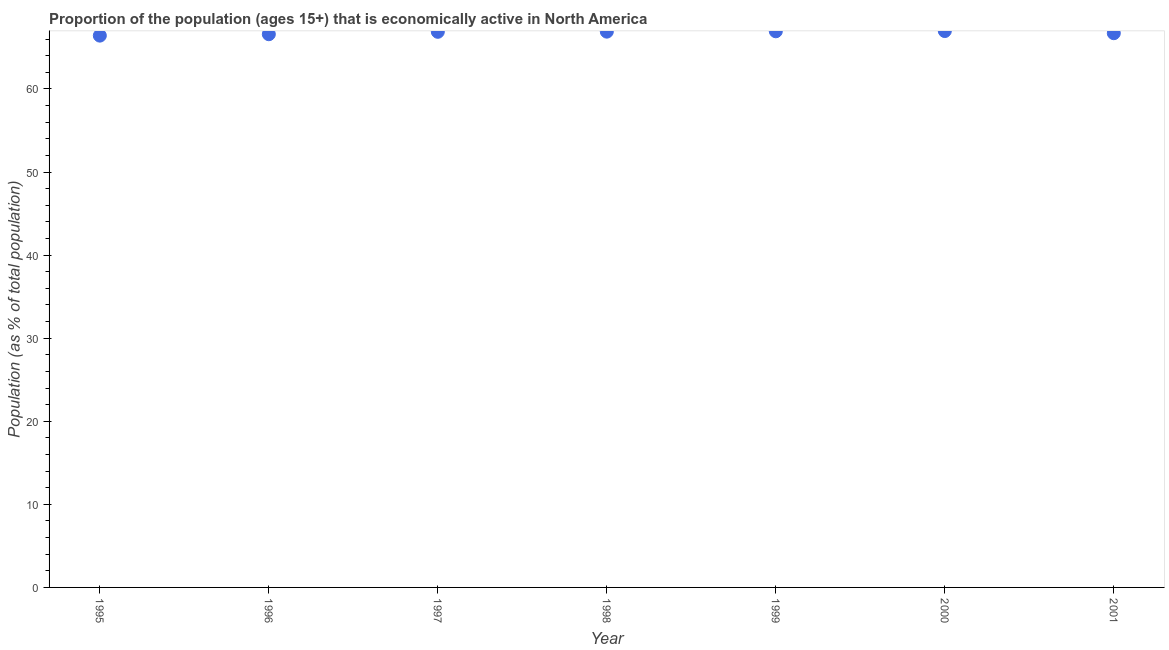What is the percentage of economically active population in 2000?
Offer a very short reply. 66.97. Across all years, what is the maximum percentage of economically active population?
Make the answer very short. 66.97. Across all years, what is the minimum percentage of economically active population?
Offer a terse response. 66.42. What is the sum of the percentage of economically active population?
Your response must be concise. 467.4. What is the difference between the percentage of economically active population in 1995 and 1996?
Your answer should be compact. -0.17. What is the average percentage of economically active population per year?
Offer a terse response. 66.77. What is the median percentage of economically active population?
Ensure brevity in your answer.  66.88. What is the ratio of the percentage of economically active population in 1995 to that in 1999?
Your response must be concise. 0.99. What is the difference between the highest and the second highest percentage of economically active population?
Ensure brevity in your answer.  0.03. What is the difference between the highest and the lowest percentage of economically active population?
Offer a terse response. 0.55. What is the difference between two consecutive major ticks on the Y-axis?
Your answer should be very brief. 10. Are the values on the major ticks of Y-axis written in scientific E-notation?
Keep it short and to the point. No. What is the title of the graph?
Ensure brevity in your answer.  Proportion of the population (ages 15+) that is economically active in North America. What is the label or title of the Y-axis?
Keep it short and to the point. Population (as % of total population). What is the Population (as % of total population) in 1995?
Provide a succinct answer. 66.42. What is the Population (as % of total population) in 1996?
Provide a short and direct response. 66.59. What is the Population (as % of total population) in 1997?
Keep it short and to the point. 66.88. What is the Population (as % of total population) in 1998?
Provide a short and direct response. 66.9. What is the Population (as % of total population) in 1999?
Your response must be concise. 66.94. What is the Population (as % of total population) in 2000?
Provide a succinct answer. 66.97. What is the Population (as % of total population) in 2001?
Your response must be concise. 66.71. What is the difference between the Population (as % of total population) in 1995 and 1996?
Provide a short and direct response. -0.17. What is the difference between the Population (as % of total population) in 1995 and 1997?
Your response must be concise. -0.46. What is the difference between the Population (as % of total population) in 1995 and 1998?
Provide a succinct answer. -0.48. What is the difference between the Population (as % of total population) in 1995 and 1999?
Your answer should be compact. -0.52. What is the difference between the Population (as % of total population) in 1995 and 2000?
Make the answer very short. -0.55. What is the difference between the Population (as % of total population) in 1995 and 2001?
Your response must be concise. -0.29. What is the difference between the Population (as % of total population) in 1996 and 1997?
Your answer should be very brief. -0.29. What is the difference between the Population (as % of total population) in 1996 and 1998?
Offer a terse response. -0.31. What is the difference between the Population (as % of total population) in 1996 and 1999?
Keep it short and to the point. -0.35. What is the difference between the Population (as % of total population) in 1996 and 2000?
Ensure brevity in your answer.  -0.38. What is the difference between the Population (as % of total population) in 1996 and 2001?
Give a very brief answer. -0.12. What is the difference between the Population (as % of total population) in 1997 and 1998?
Your answer should be compact. -0.02. What is the difference between the Population (as % of total population) in 1997 and 1999?
Offer a very short reply. -0.06. What is the difference between the Population (as % of total population) in 1997 and 2000?
Your answer should be compact. -0.09. What is the difference between the Population (as % of total population) in 1997 and 2001?
Your answer should be compact. 0.17. What is the difference between the Population (as % of total population) in 1998 and 1999?
Keep it short and to the point. -0.04. What is the difference between the Population (as % of total population) in 1998 and 2000?
Provide a short and direct response. -0.07. What is the difference between the Population (as % of total population) in 1998 and 2001?
Keep it short and to the point. 0.19. What is the difference between the Population (as % of total population) in 1999 and 2000?
Your response must be concise. -0.03. What is the difference between the Population (as % of total population) in 1999 and 2001?
Provide a short and direct response. 0.23. What is the difference between the Population (as % of total population) in 2000 and 2001?
Ensure brevity in your answer.  0.26. What is the ratio of the Population (as % of total population) in 1995 to that in 1996?
Offer a terse response. 1. What is the ratio of the Population (as % of total population) in 1995 to that in 1999?
Offer a terse response. 0.99. What is the ratio of the Population (as % of total population) in 1995 to that in 2001?
Your answer should be very brief. 1. What is the ratio of the Population (as % of total population) in 1996 to that in 1998?
Your answer should be very brief. 0.99. What is the ratio of the Population (as % of total population) in 1996 to that in 2001?
Ensure brevity in your answer.  1. What is the ratio of the Population (as % of total population) in 1997 to that in 1998?
Keep it short and to the point. 1. What is the ratio of the Population (as % of total population) in 1997 to that in 2000?
Provide a short and direct response. 1. What is the ratio of the Population (as % of total population) in 1998 to that in 2000?
Provide a short and direct response. 1. What is the ratio of the Population (as % of total population) in 1999 to that in 2000?
Offer a very short reply. 1. What is the ratio of the Population (as % of total population) in 2000 to that in 2001?
Ensure brevity in your answer.  1. 